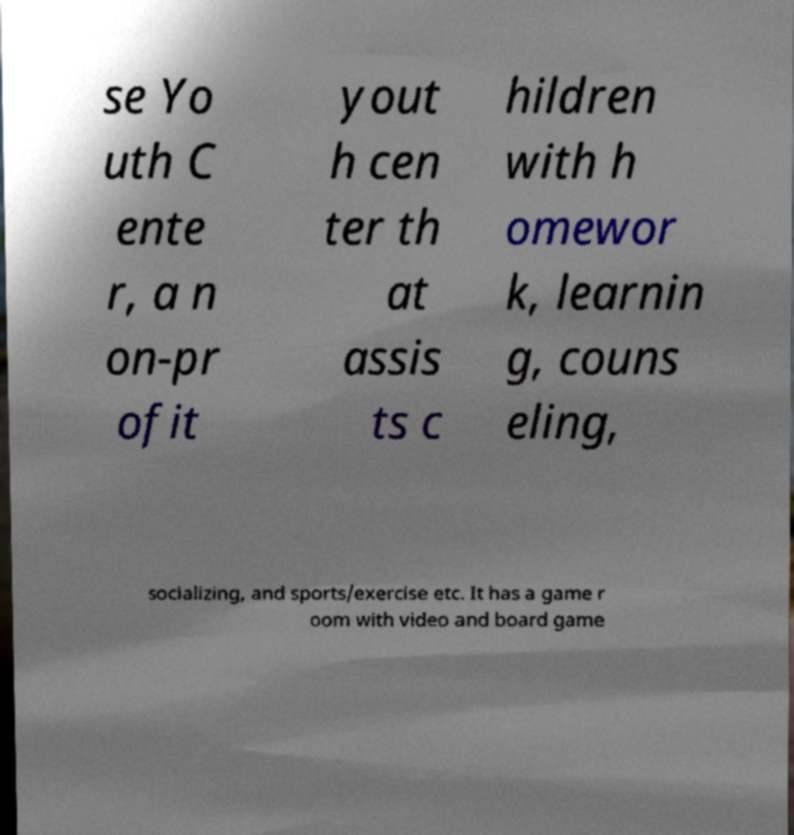There's text embedded in this image that I need extracted. Can you transcribe it verbatim? se Yo uth C ente r, a n on-pr ofit yout h cen ter th at assis ts c hildren with h omewor k, learnin g, couns eling, socializing, and sports/exercise etc. It has a game r oom with video and board game 